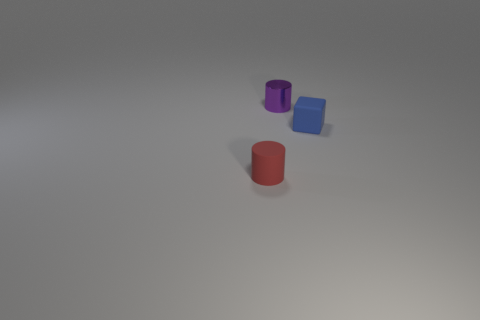Are there any blue matte blocks to the left of the small red rubber cylinder?
Offer a very short reply. No. The rubber object that is to the left of the rubber object behind the thing that is in front of the small blue cube is what color?
Give a very brief answer. Red. What is the shape of the metal thing that is the same size as the blue matte thing?
Ensure brevity in your answer.  Cylinder. Are there more big yellow cylinders than matte things?
Make the answer very short. No. There is a small matte thing that is in front of the rubber cube; are there any blue cubes that are behind it?
Offer a terse response. Yes. The rubber object that is the same shape as the tiny purple metal object is what color?
Ensure brevity in your answer.  Red. Are there any other things that have the same shape as the purple shiny object?
Your answer should be compact. Yes. There is a thing that is made of the same material as the small red cylinder; what is its color?
Keep it short and to the point. Blue. There is a tiny cylinder that is behind the object that is in front of the cube; are there any tiny red matte cylinders left of it?
Make the answer very short. Yes. Are there fewer purple shiny cylinders that are in front of the metal thing than tiny blue cubes on the left side of the small matte cube?
Give a very brief answer. No. 